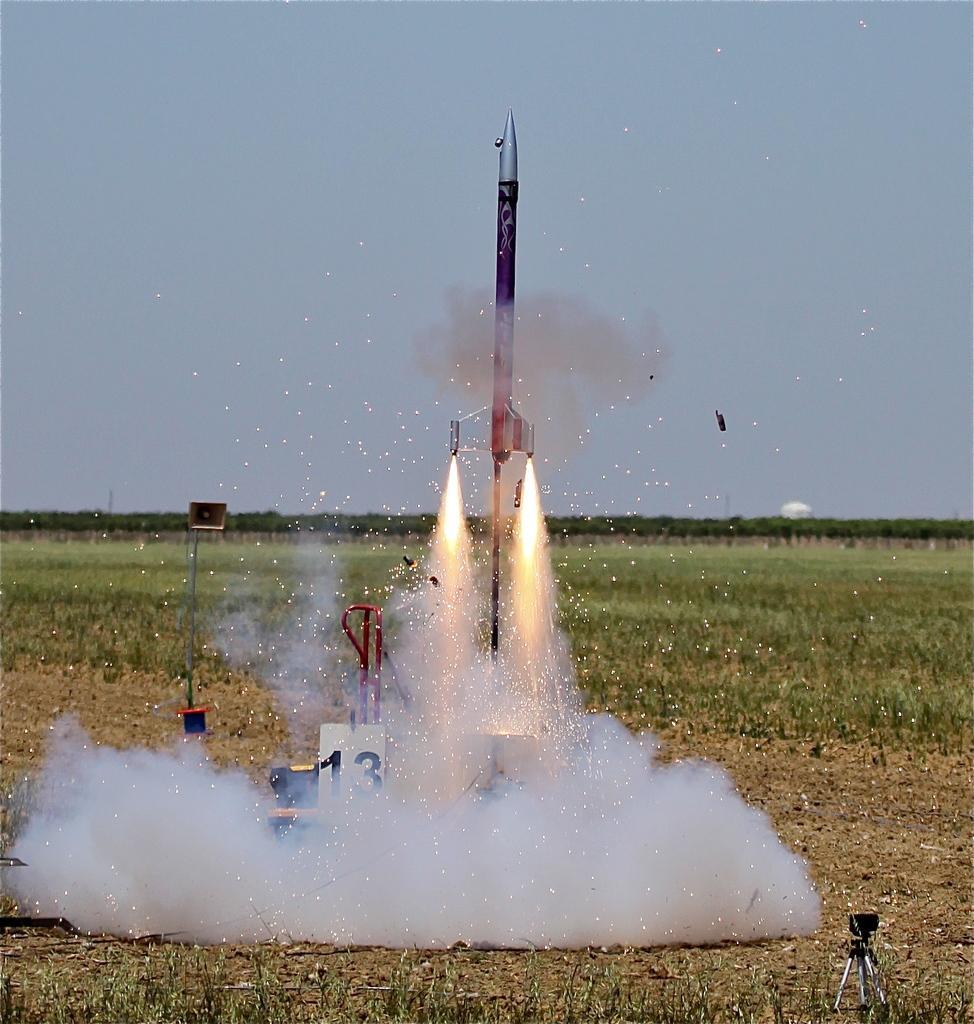How would you summarize this image in a sentence or two? Here in this picture we can see a rocket launched in the air and behind that we can see smoke and fire present and we can see the ground is fully covered with grass and we can also see a camera in the right bottom side and in the far we can see trees covered , that are in blurry manner and we can see the sky is cloudy and we can also see moon present in the sky. 